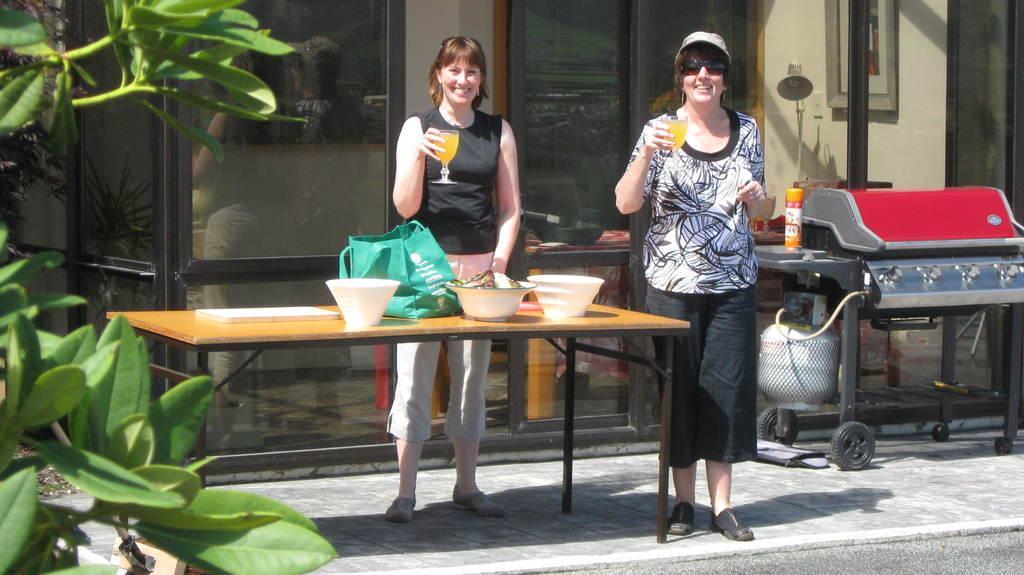Describe this image in one or two sentences. In this image there are two girls in the middle who are holding the glass with their hands. In front of them there is a table on which there are bowls and covers. On the left side there are plants. In the background there is a building. On the right side there is a trolley. There is juice in the glasses. 